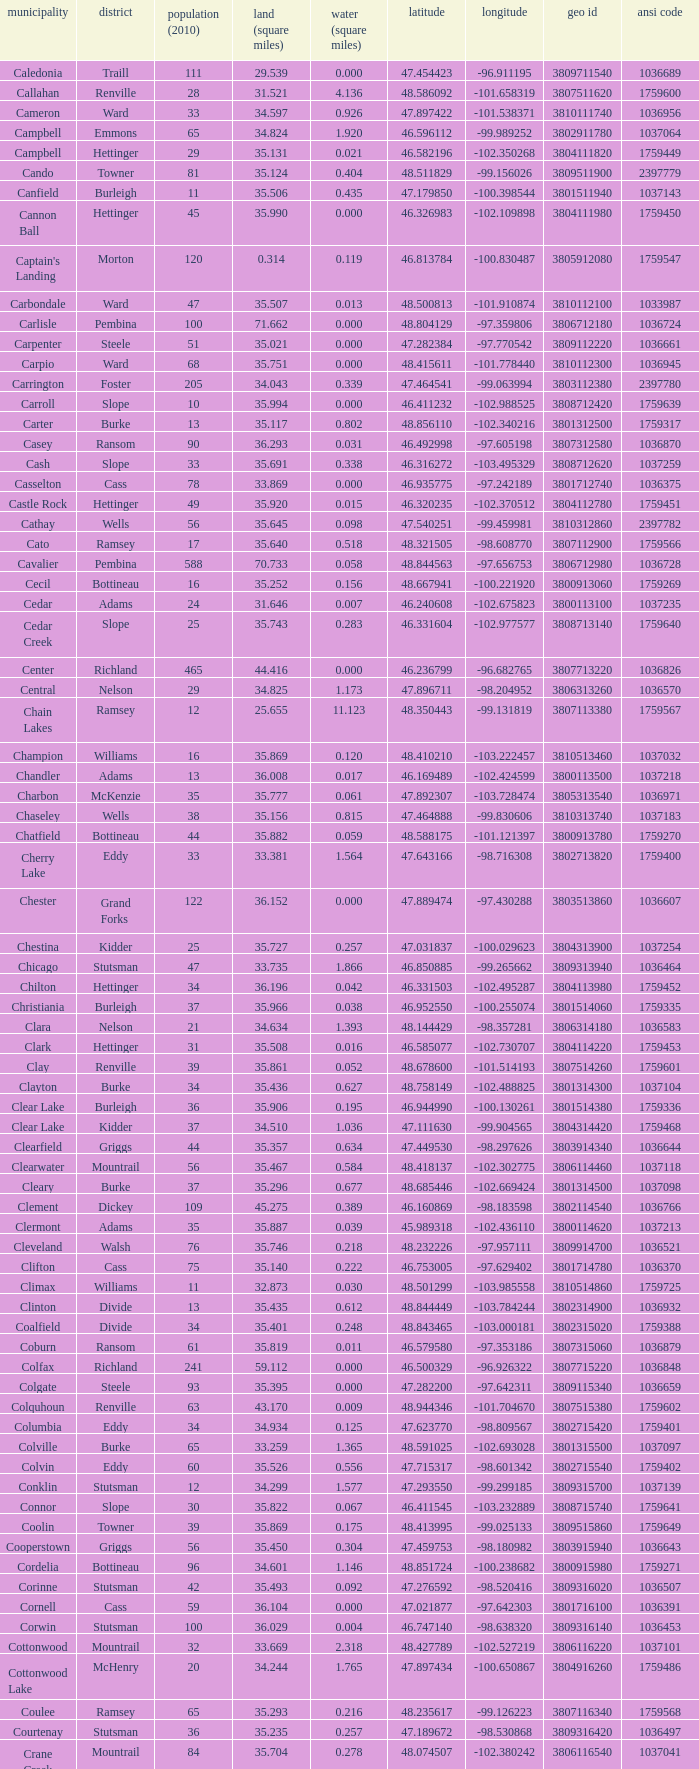What was the longitude of the township with a latitude of 48.075823? -98.857272. 